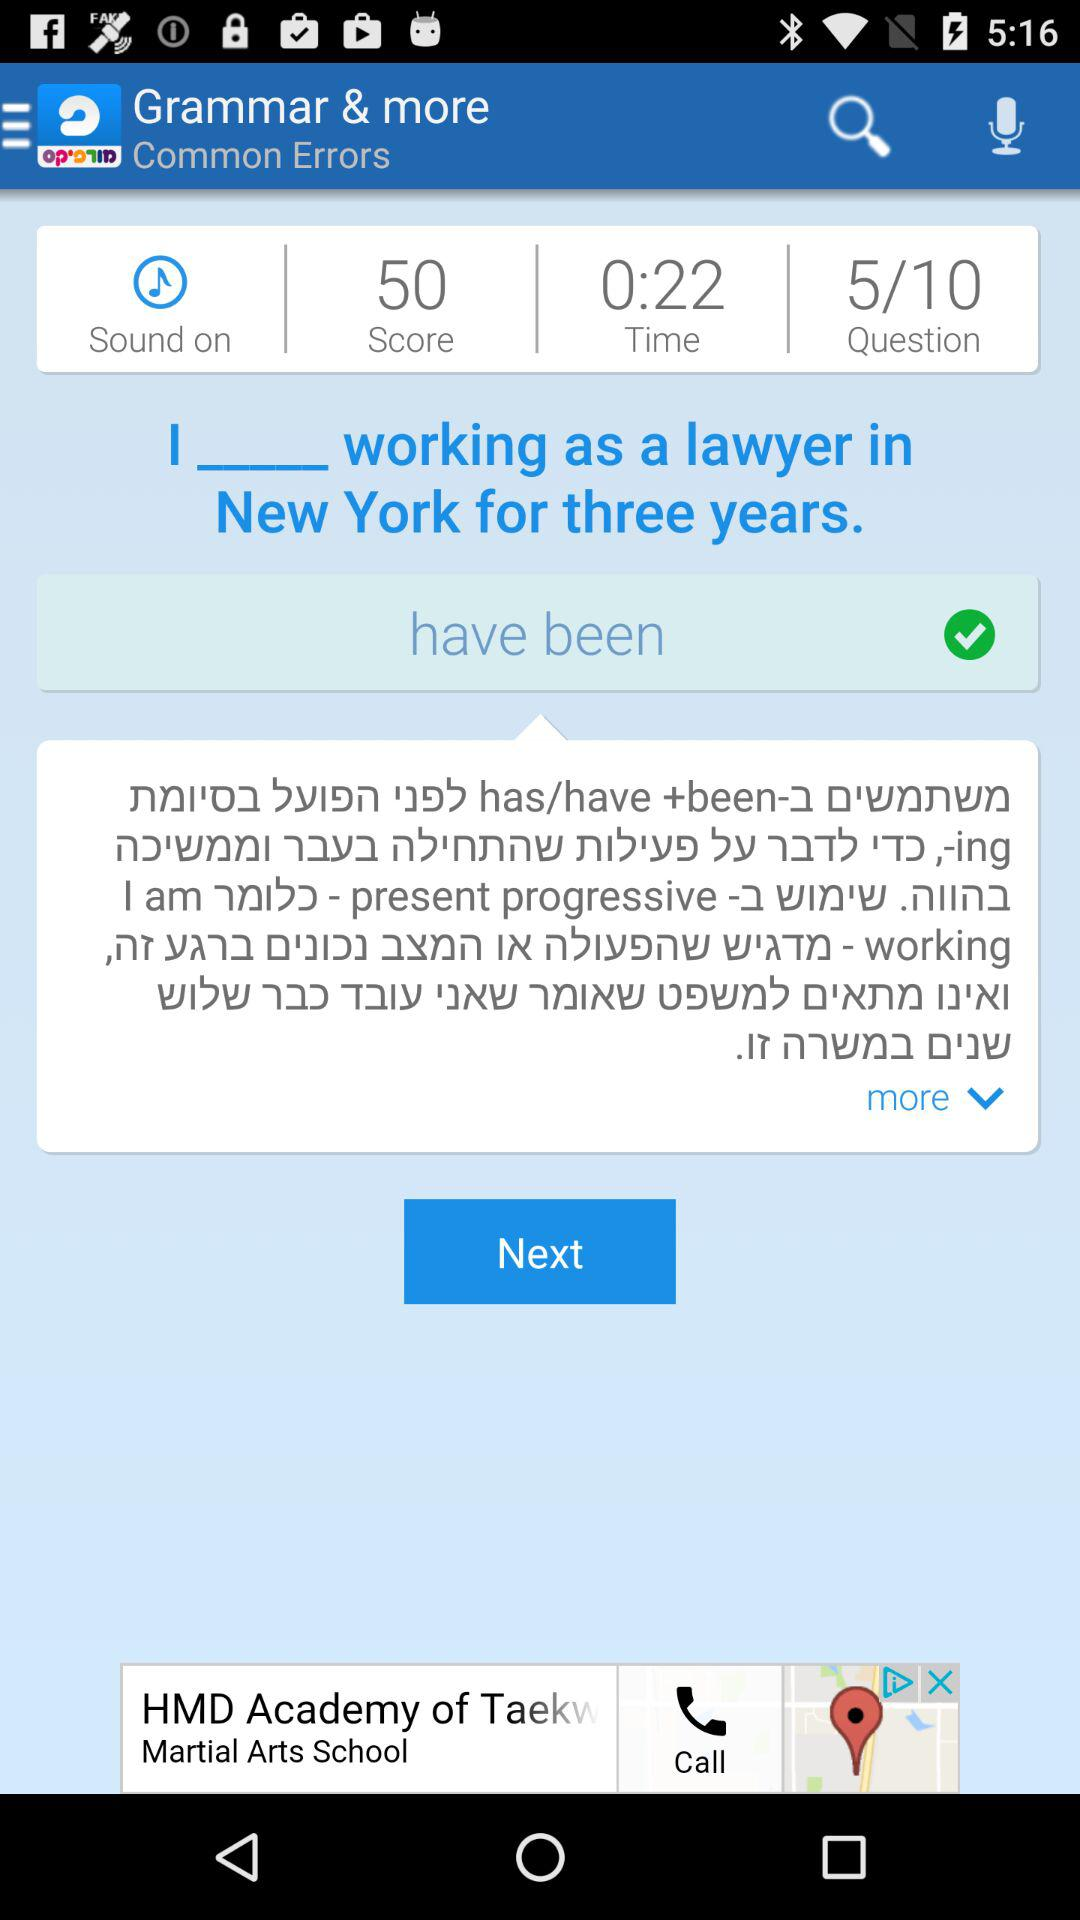What is the total number of questions? The total number of questions is 10. 